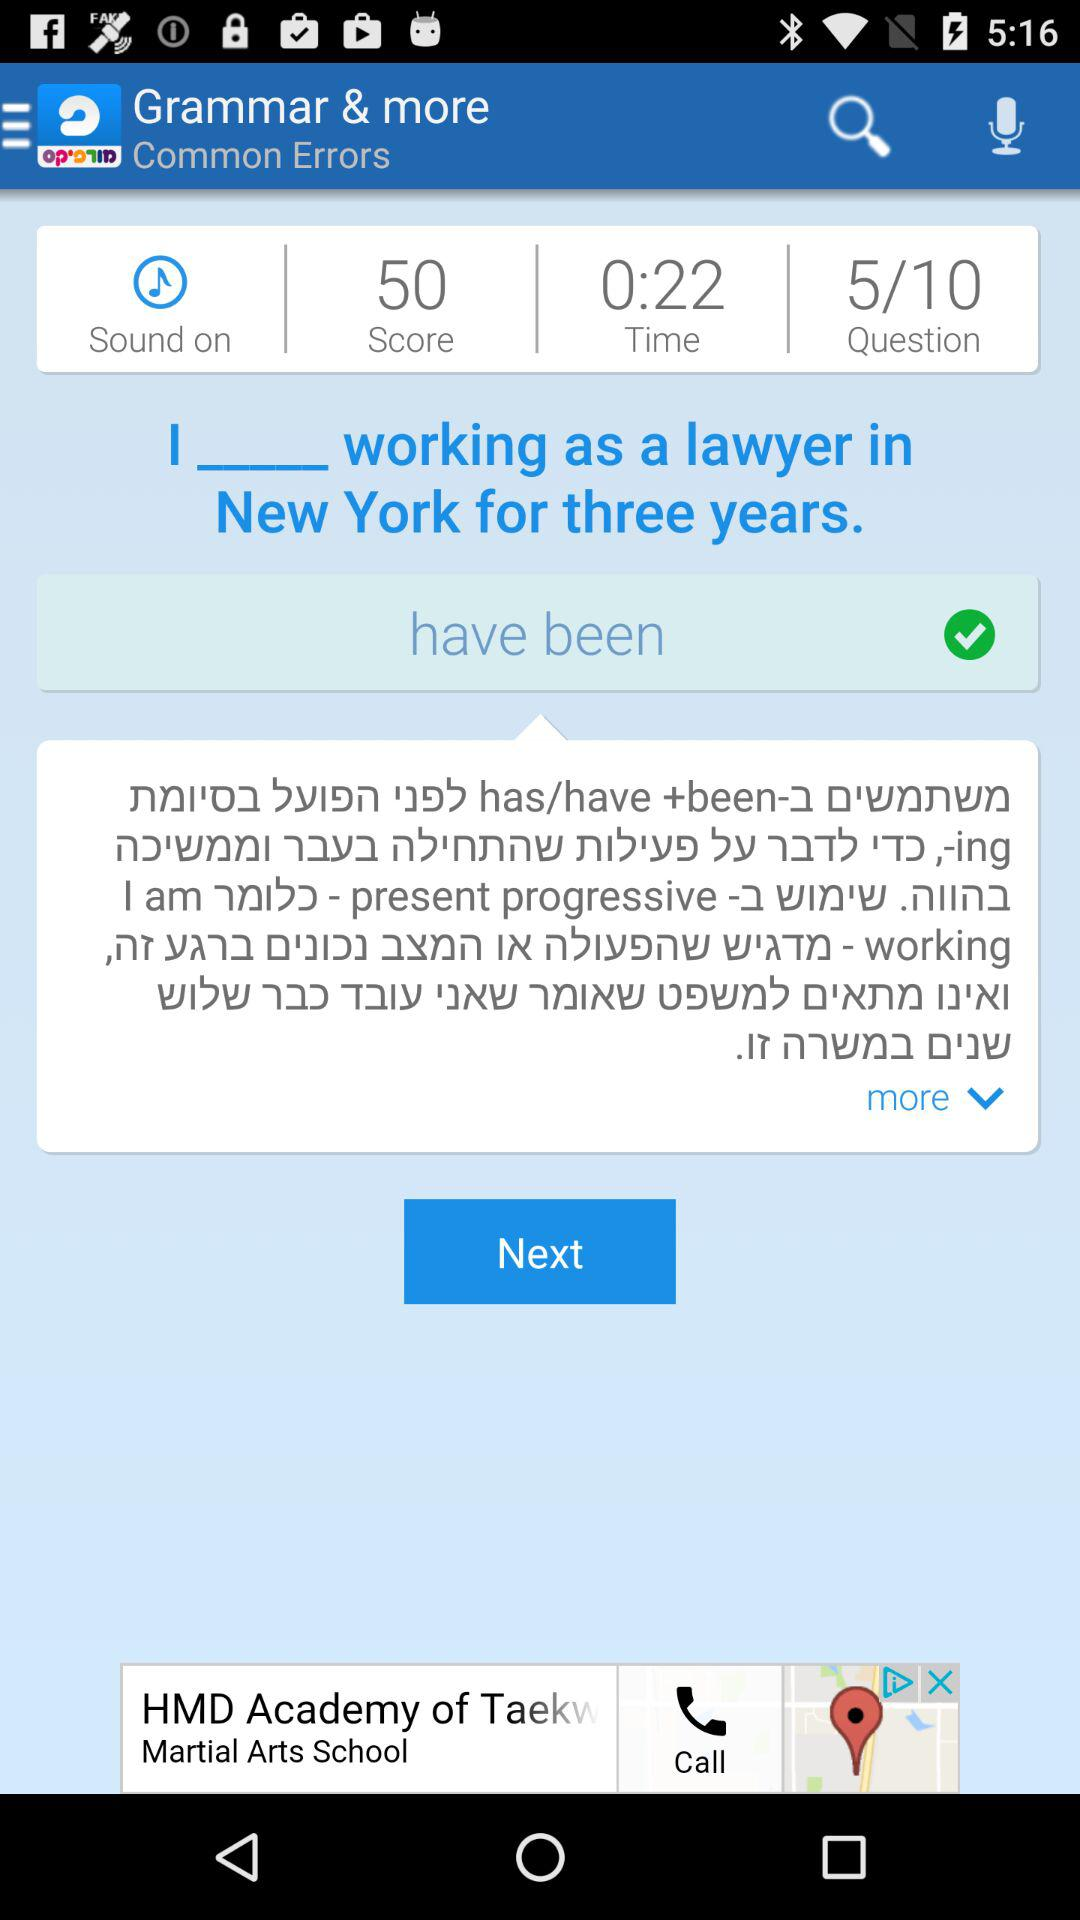What is the total number of questions? The total number of questions is 10. 